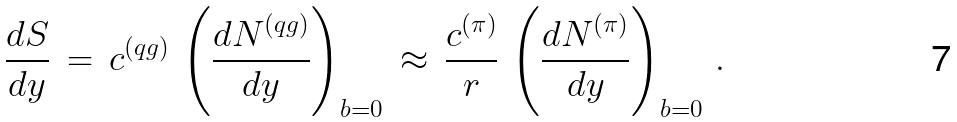Convert formula to latex. <formula><loc_0><loc_0><loc_500><loc_500>\frac { d S } { d y } \, = \, c ^ { ( q g ) } \, \left ( \frac { d N ^ { ( q g ) } } { d y } \right ) _ { b = 0 } \, \approx \, \frac { c ^ { ( \pi ) } } { r } \, \left ( \frac { d N ^ { ( \pi ) } } { d y } \right ) _ { b = 0 } \, .</formula> 